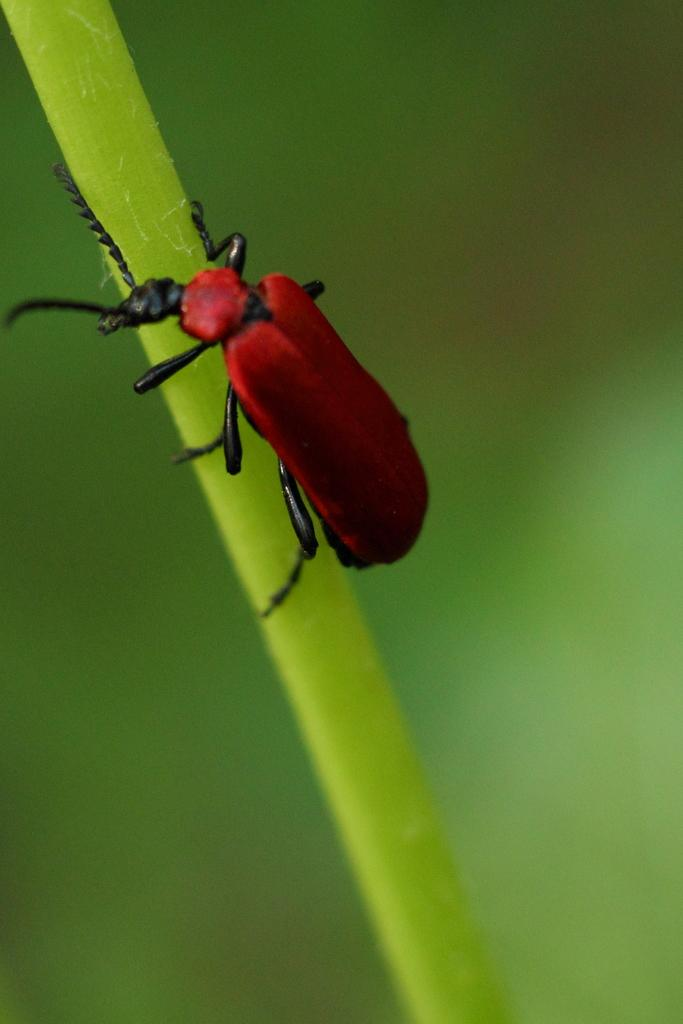What type of insect is in the image? There is a soldier beetle in the image. Where is the soldier beetle located? The soldier beetle is present on a plant. How many snakes are present in the image? There are no snakes present in the image; it features a soldier beetle on a plant. What is the best way to crush the soldier beetle in the image? There is no need to crush the soldier beetle, as it is not causing any harm or disruption in the image. 